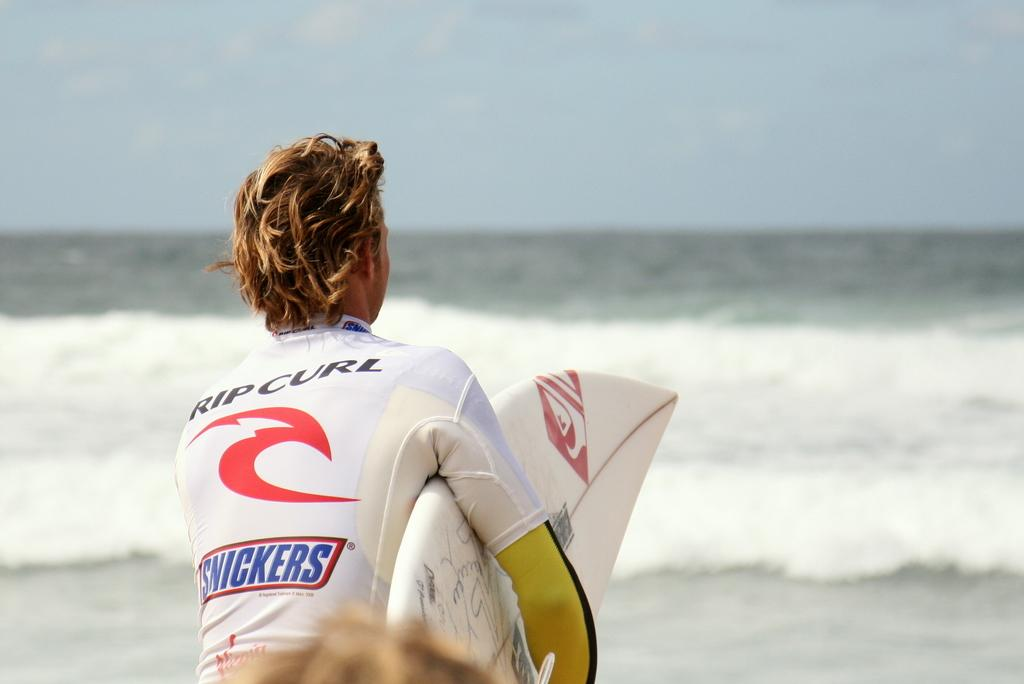What part of a person can be seen at the bottom of the image? There is a person's hair visible at the bottom of the image. What is the person holding in the foreground? The person is holding a surfboard in the foreground. What can be seen in the center of the image? There is a water body in the center of the image. What is visible at the top of the image? The sky is visible at the top of the image. Can you see a goose swimming in the water body in the image? There is no goose present in the image; it only features a person holding a surfboard and a water body. What type of edge is visible at the top of the image? There is no edge visible at the top of the image; it is the sky that is visible. 